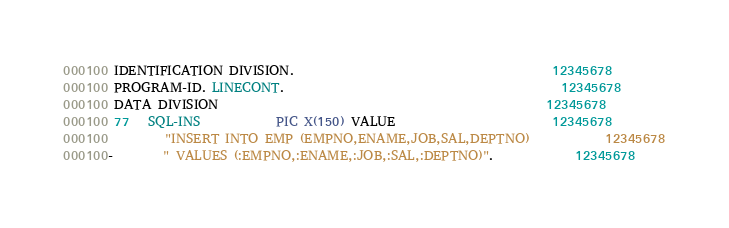<code> <loc_0><loc_0><loc_500><loc_500><_COBOL_>000100 IDENTIFICATION DIVISION.                                         12345678
000100 PROGRAM-ID. LINECONT.                                            12345678
000100 DATA DIVISION                                                    12345678
000100 77   SQL-INS            PIC X(150) VALUE                         12345678
000100         "INSERT INTO EMP (EMPNO,ENAME,JOB,SAL,DEPTNO)            12345678
000100-        " VALUES (:EMPNO,:ENAME,:JOB,:SAL,:DEPTNO)".             12345678</code> 